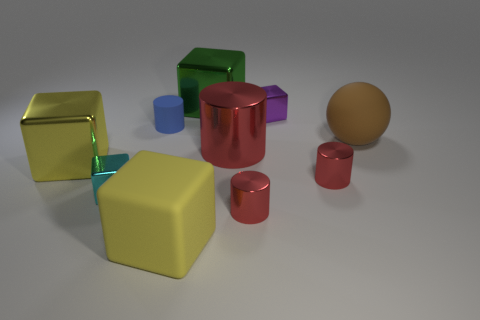Subtract all yellow balls. How many red cylinders are left? 3 Subtract 2 blocks. How many blocks are left? 3 Subtract all purple blocks. How many blocks are left? 4 Subtract all small purple cubes. How many cubes are left? 4 Subtract all brown blocks. Subtract all purple spheres. How many blocks are left? 5 Subtract all cylinders. How many objects are left? 6 Add 9 cyan rubber things. How many cyan rubber things exist? 9 Subtract 0 gray cylinders. How many objects are left? 10 Subtract all big yellow rubber cubes. Subtract all brown objects. How many objects are left? 8 Add 8 large green metallic cubes. How many large green metallic cubes are left? 9 